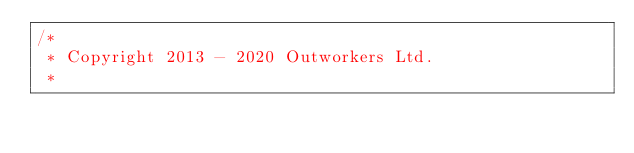<code> <loc_0><loc_0><loc_500><loc_500><_Scala_>/*
 * Copyright 2013 - 2020 Outworkers Ltd.
 *</code> 